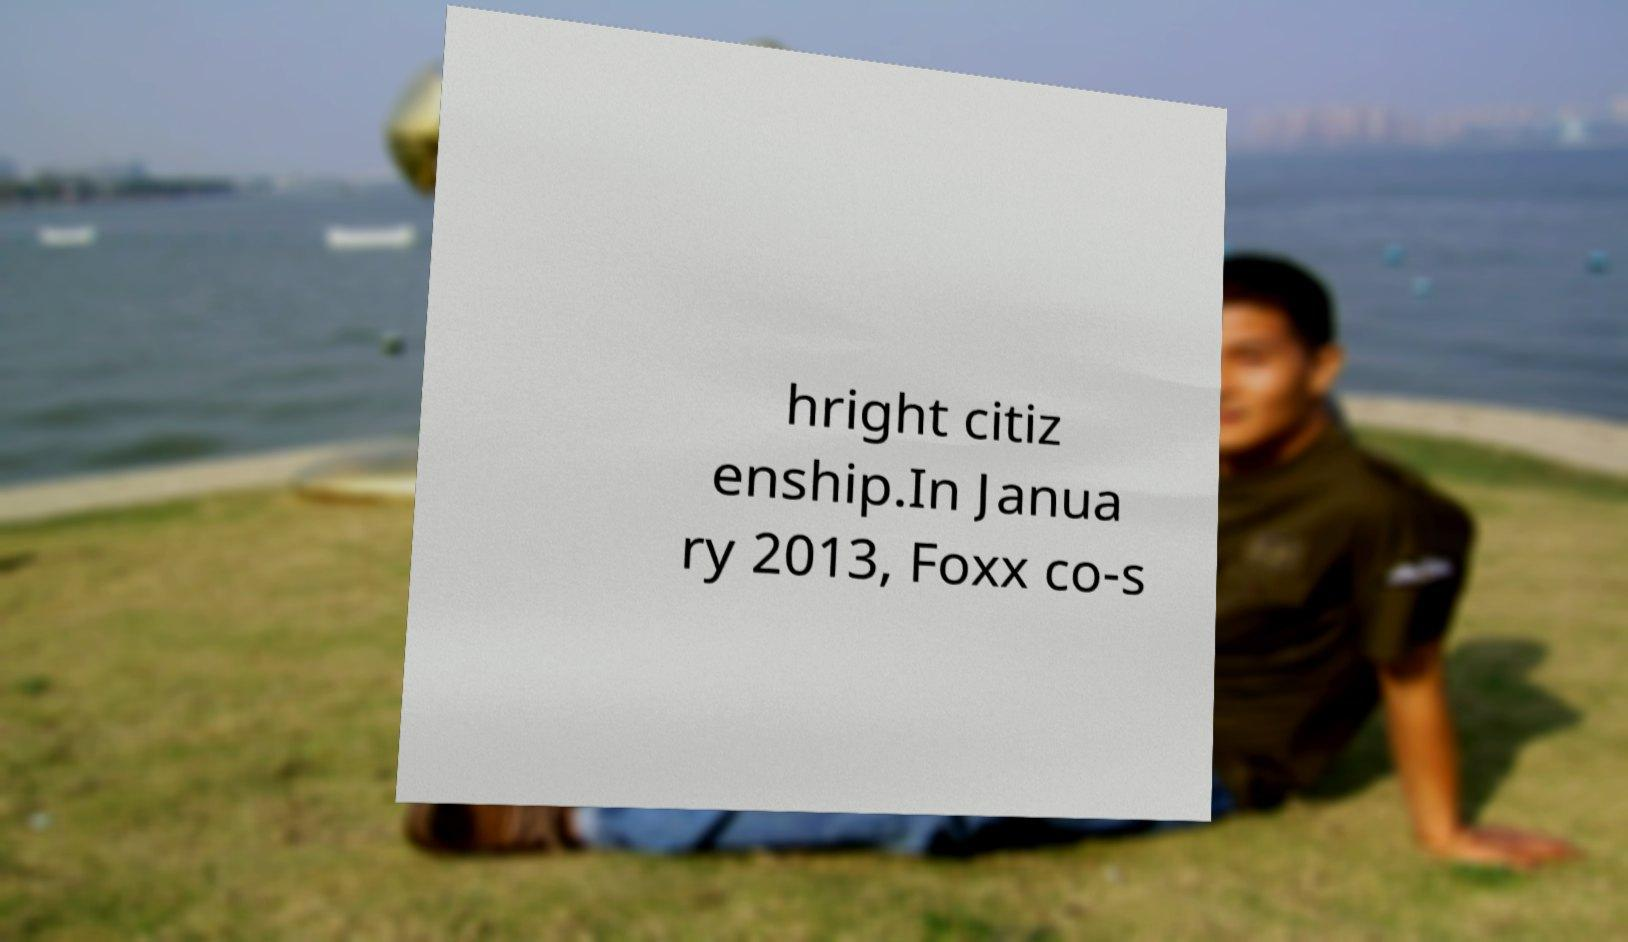Please read and relay the text visible in this image. What does it say? hright citiz enship.In Janua ry 2013, Foxx co-s 